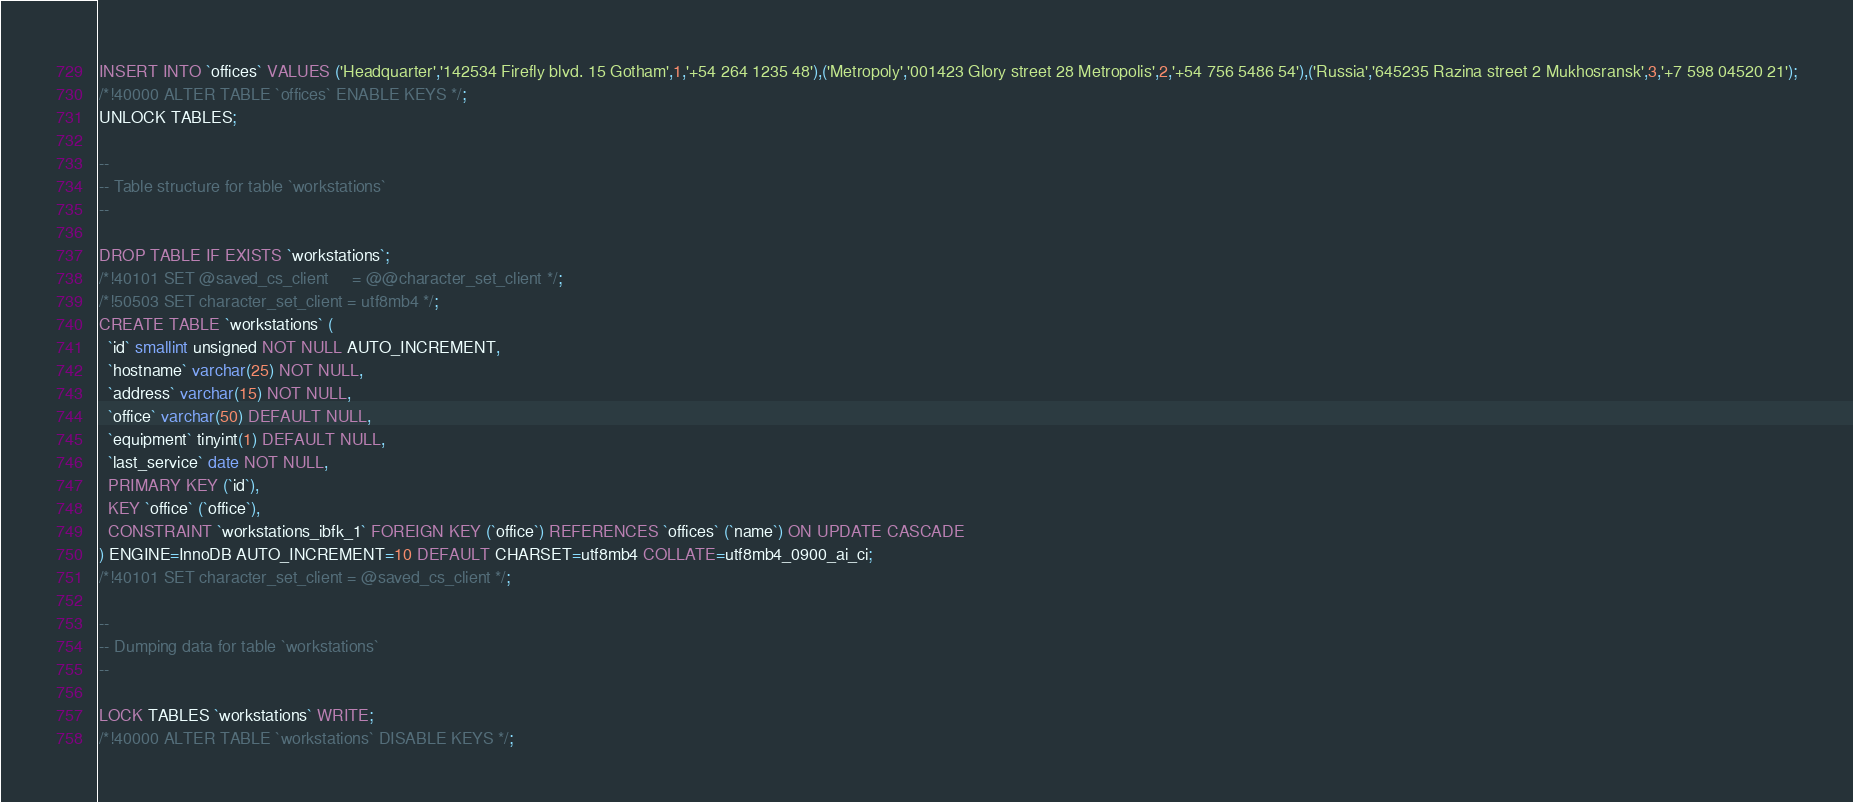<code> <loc_0><loc_0><loc_500><loc_500><_SQL_>INSERT INTO `offices` VALUES ('Headquarter','142534 Firefly blvd. 15 Gotham',1,'+54 264 1235 48'),('Metropoly','001423 Glory street 28 Metropolis',2,'+54 756 5486 54'),('Russia','645235 Razina street 2 Mukhosransk',3,'+7 598 04520 21');
/*!40000 ALTER TABLE `offices` ENABLE KEYS */;
UNLOCK TABLES;

--
-- Table structure for table `workstations`
--

DROP TABLE IF EXISTS `workstations`;
/*!40101 SET @saved_cs_client     = @@character_set_client */;
/*!50503 SET character_set_client = utf8mb4 */;
CREATE TABLE `workstations` (
  `id` smallint unsigned NOT NULL AUTO_INCREMENT,
  `hostname` varchar(25) NOT NULL,
  `address` varchar(15) NOT NULL,
  `office` varchar(50) DEFAULT NULL,
  `equipment` tinyint(1) DEFAULT NULL,
  `last_service` date NOT NULL,
  PRIMARY KEY (`id`),
  KEY `office` (`office`),
  CONSTRAINT `workstations_ibfk_1` FOREIGN KEY (`office`) REFERENCES `offices` (`name`) ON UPDATE CASCADE
) ENGINE=InnoDB AUTO_INCREMENT=10 DEFAULT CHARSET=utf8mb4 COLLATE=utf8mb4_0900_ai_ci;
/*!40101 SET character_set_client = @saved_cs_client */;

--
-- Dumping data for table `workstations`
--

LOCK TABLES `workstations` WRITE;
/*!40000 ALTER TABLE `workstations` DISABLE KEYS */;</code> 